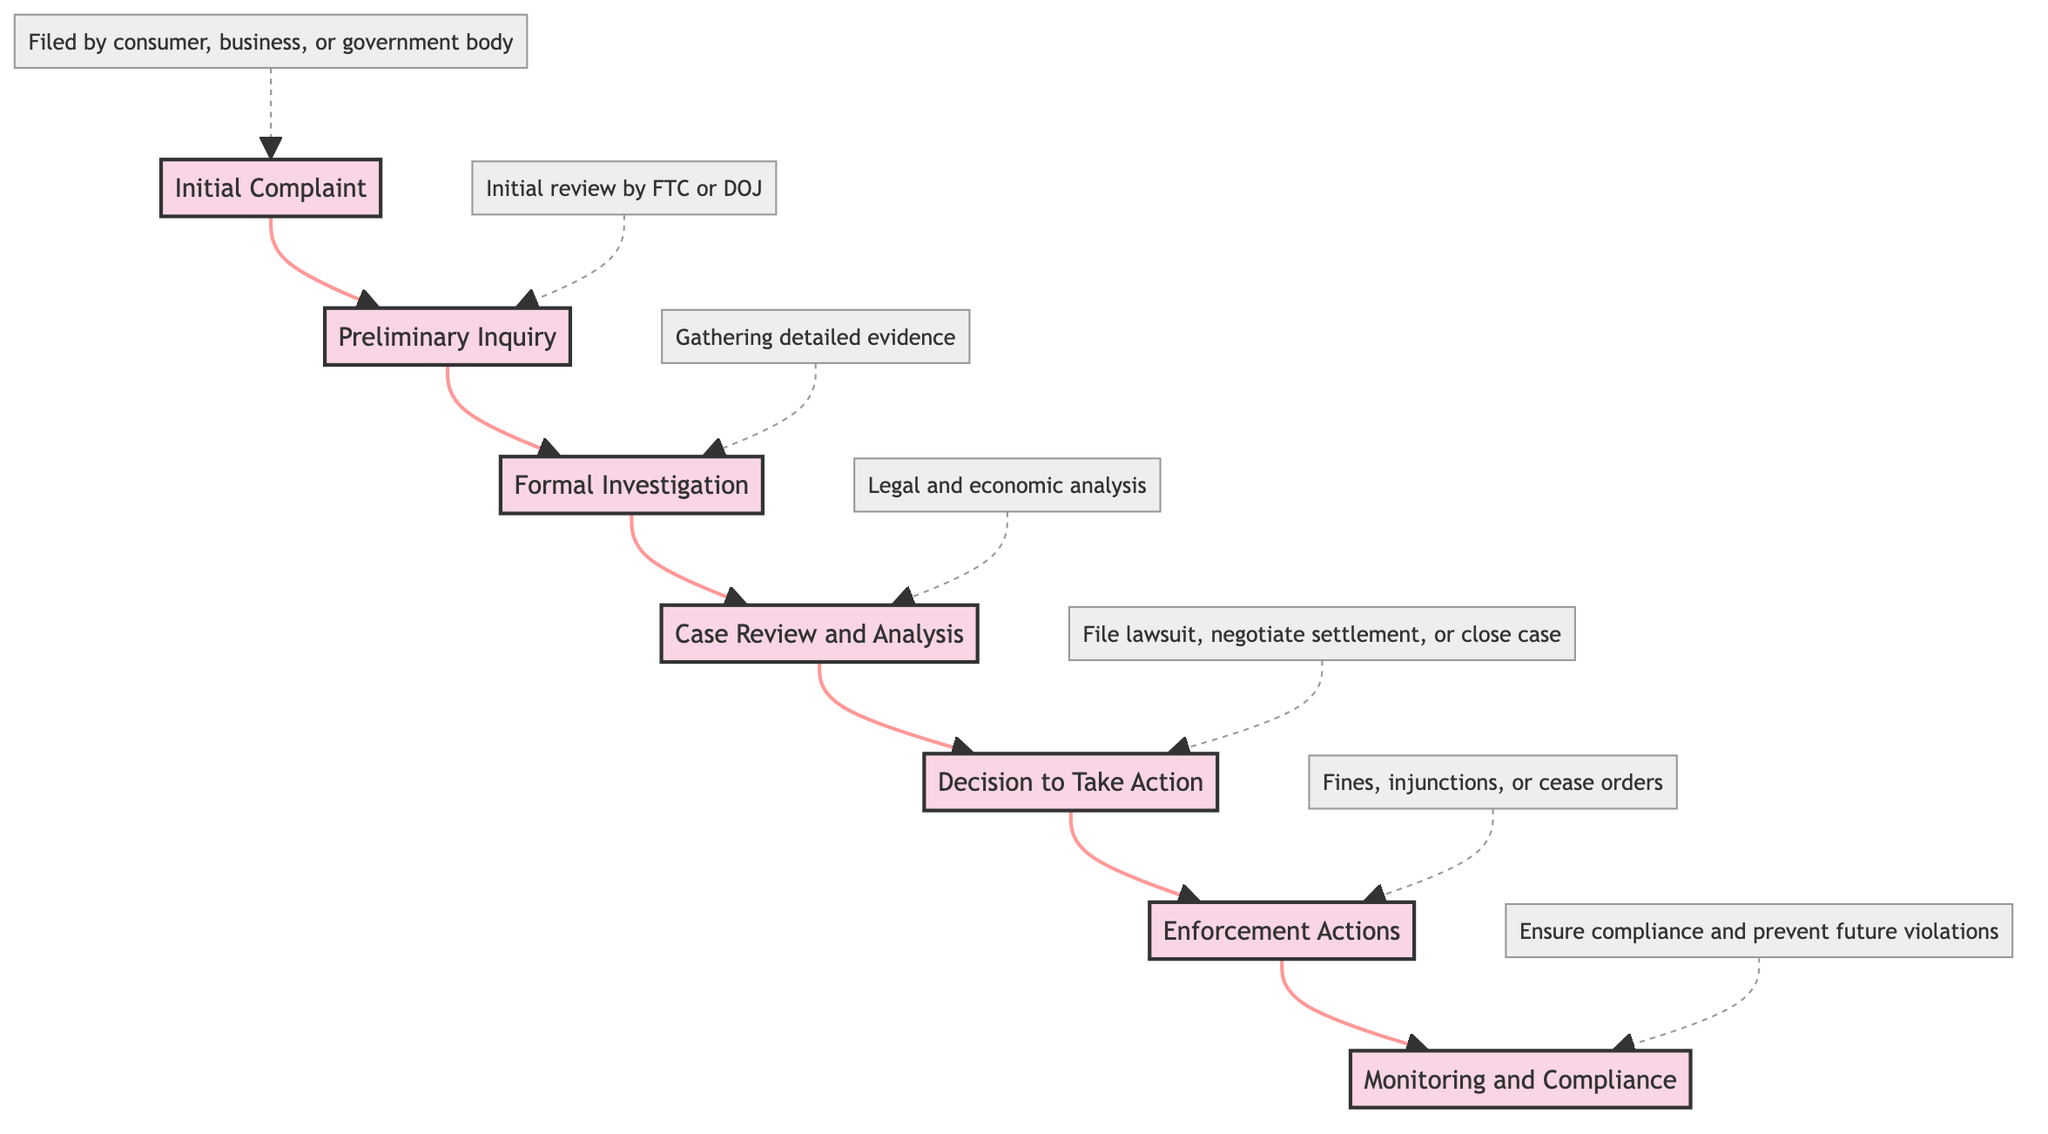What is the first stage of regulatory review? The diagram lists "Initial Complaint" as the topmost stage, clearly indicating that it is the starting point of the regulatory review process.
Answer: Initial Complaint Which authorities conduct the preliminary inquiry? The diagram states that the preliminary inquiry is conducted by the FTC or DOJ, showing the specific regulatory bodies responsible for this step.
Answer: FTC or DOJ What happens if potential antitrust issues are found during the preliminary inquiry? According to the diagram, if potential issues are identified, a "Formal Investigation" is launched, indicating the next step in the review process.
Answer: Formal Investigation How many stages are involved in the regulatory review process? The diagram contains a total of seven distinct stages, each representing a specific step in the review process.
Answer: Seven What actions might regulatory authorities decide to take after the case review and analysis? The diagram describes three possible actions: filing a lawsuit, negotiating a settlement, or closing the case, detailing the options available to authorities.
Answer: File lawsuit, negotiate settlement, or close case What follows enforcement actions in the regulatory review process? The flow chart indicates that after enforcement actions are taken, the next stage is "Monitoring and Compliance," which ensures adherence to regulatory measures.
Answer: Monitoring and Compliance Which stage involves legal and economic analysis? The diagram identifies "Case Review and Analysis" as the stage where legal and economic analysis takes place, emphasizing its importance in the review process.
Answer: Case Review and Analysis How are the stages connected in this flow chart? The diagram illustrates a linear progression from one stage to the next, showing a clear flow from the initial complaint to monitoring and compliance, demonstrating the process's sequential nature.
Answer: Linear progression What is the final enforcement measure mentioned in the diagram? The last action listed in the diagram is "Monitoring and Compliance," which indicates ongoing measures to ensure adherence to any regulatory actions taken.
Answer: Monitoring and Compliance 